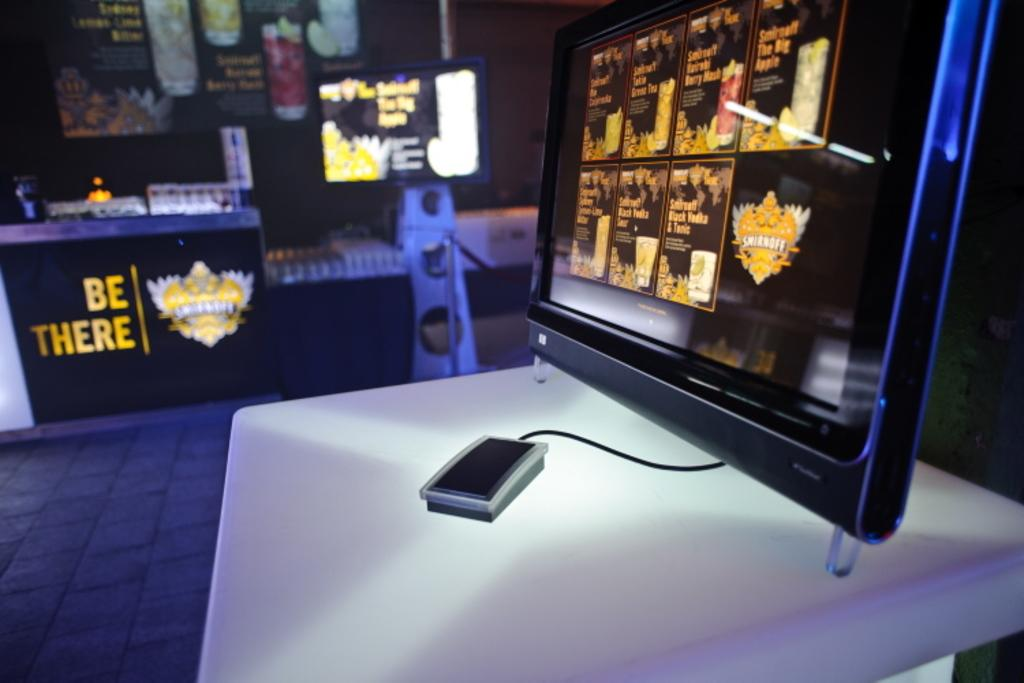<image>
Describe the image concisely. A table says "BE THERE" and features a gold crest next to the text. 